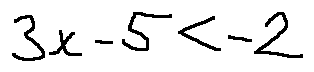Convert formula to latex. <formula><loc_0><loc_0><loc_500><loc_500>3 x - 5 < - 2</formula> 